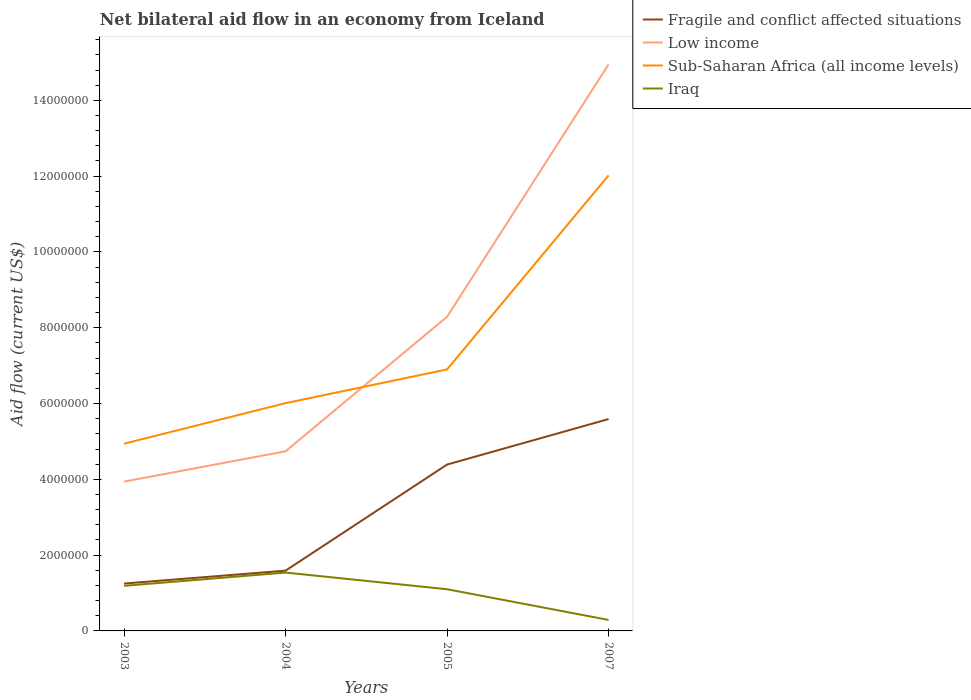How many different coloured lines are there?
Ensure brevity in your answer.  4. Does the line corresponding to Iraq intersect with the line corresponding to Sub-Saharan Africa (all income levels)?
Offer a very short reply. No. Across all years, what is the maximum net bilateral aid flow in Sub-Saharan Africa (all income levels)?
Give a very brief answer. 4.94e+06. In which year was the net bilateral aid flow in Fragile and conflict affected situations maximum?
Ensure brevity in your answer.  2003. What is the total net bilateral aid flow in Low income in the graph?
Ensure brevity in your answer.  -6.66e+06. What is the difference between the highest and the second highest net bilateral aid flow in Low income?
Ensure brevity in your answer.  1.10e+07. What is the difference between two consecutive major ticks on the Y-axis?
Your answer should be very brief. 2.00e+06. Are the values on the major ticks of Y-axis written in scientific E-notation?
Ensure brevity in your answer.  No. Does the graph contain grids?
Ensure brevity in your answer.  No. Where does the legend appear in the graph?
Your response must be concise. Top right. How are the legend labels stacked?
Ensure brevity in your answer.  Vertical. What is the title of the graph?
Give a very brief answer. Net bilateral aid flow in an economy from Iceland. What is the Aid flow (current US$) of Fragile and conflict affected situations in 2003?
Provide a succinct answer. 1.25e+06. What is the Aid flow (current US$) in Low income in 2003?
Provide a succinct answer. 3.94e+06. What is the Aid flow (current US$) in Sub-Saharan Africa (all income levels) in 2003?
Provide a short and direct response. 4.94e+06. What is the Aid flow (current US$) of Iraq in 2003?
Give a very brief answer. 1.19e+06. What is the Aid flow (current US$) in Fragile and conflict affected situations in 2004?
Your answer should be compact. 1.59e+06. What is the Aid flow (current US$) in Low income in 2004?
Provide a short and direct response. 4.74e+06. What is the Aid flow (current US$) in Sub-Saharan Africa (all income levels) in 2004?
Your answer should be compact. 6.01e+06. What is the Aid flow (current US$) in Iraq in 2004?
Your answer should be very brief. 1.54e+06. What is the Aid flow (current US$) of Fragile and conflict affected situations in 2005?
Make the answer very short. 4.39e+06. What is the Aid flow (current US$) in Low income in 2005?
Your response must be concise. 8.29e+06. What is the Aid flow (current US$) in Sub-Saharan Africa (all income levels) in 2005?
Your response must be concise. 6.90e+06. What is the Aid flow (current US$) in Iraq in 2005?
Your answer should be very brief. 1.10e+06. What is the Aid flow (current US$) of Fragile and conflict affected situations in 2007?
Offer a very short reply. 5.59e+06. What is the Aid flow (current US$) in Low income in 2007?
Your answer should be very brief. 1.50e+07. What is the Aid flow (current US$) in Sub-Saharan Africa (all income levels) in 2007?
Your response must be concise. 1.20e+07. What is the Aid flow (current US$) in Iraq in 2007?
Your answer should be compact. 2.90e+05. Across all years, what is the maximum Aid flow (current US$) of Fragile and conflict affected situations?
Provide a short and direct response. 5.59e+06. Across all years, what is the maximum Aid flow (current US$) of Low income?
Ensure brevity in your answer.  1.50e+07. Across all years, what is the maximum Aid flow (current US$) of Sub-Saharan Africa (all income levels)?
Your answer should be very brief. 1.20e+07. Across all years, what is the maximum Aid flow (current US$) of Iraq?
Ensure brevity in your answer.  1.54e+06. Across all years, what is the minimum Aid flow (current US$) in Fragile and conflict affected situations?
Keep it short and to the point. 1.25e+06. Across all years, what is the minimum Aid flow (current US$) in Low income?
Ensure brevity in your answer.  3.94e+06. Across all years, what is the minimum Aid flow (current US$) in Sub-Saharan Africa (all income levels)?
Offer a very short reply. 4.94e+06. Across all years, what is the minimum Aid flow (current US$) in Iraq?
Ensure brevity in your answer.  2.90e+05. What is the total Aid flow (current US$) in Fragile and conflict affected situations in the graph?
Your answer should be very brief. 1.28e+07. What is the total Aid flow (current US$) of Low income in the graph?
Make the answer very short. 3.19e+07. What is the total Aid flow (current US$) of Sub-Saharan Africa (all income levels) in the graph?
Make the answer very short. 2.99e+07. What is the total Aid flow (current US$) of Iraq in the graph?
Make the answer very short. 4.12e+06. What is the difference between the Aid flow (current US$) in Low income in 2003 and that in 2004?
Keep it short and to the point. -8.00e+05. What is the difference between the Aid flow (current US$) in Sub-Saharan Africa (all income levels) in 2003 and that in 2004?
Your response must be concise. -1.07e+06. What is the difference between the Aid flow (current US$) of Iraq in 2003 and that in 2004?
Give a very brief answer. -3.50e+05. What is the difference between the Aid flow (current US$) in Fragile and conflict affected situations in 2003 and that in 2005?
Provide a succinct answer. -3.14e+06. What is the difference between the Aid flow (current US$) of Low income in 2003 and that in 2005?
Keep it short and to the point. -4.35e+06. What is the difference between the Aid flow (current US$) of Sub-Saharan Africa (all income levels) in 2003 and that in 2005?
Make the answer very short. -1.96e+06. What is the difference between the Aid flow (current US$) in Iraq in 2003 and that in 2005?
Provide a short and direct response. 9.00e+04. What is the difference between the Aid flow (current US$) of Fragile and conflict affected situations in 2003 and that in 2007?
Offer a very short reply. -4.34e+06. What is the difference between the Aid flow (current US$) in Low income in 2003 and that in 2007?
Your answer should be compact. -1.10e+07. What is the difference between the Aid flow (current US$) in Sub-Saharan Africa (all income levels) in 2003 and that in 2007?
Offer a terse response. -7.08e+06. What is the difference between the Aid flow (current US$) in Fragile and conflict affected situations in 2004 and that in 2005?
Your response must be concise. -2.80e+06. What is the difference between the Aid flow (current US$) of Low income in 2004 and that in 2005?
Make the answer very short. -3.55e+06. What is the difference between the Aid flow (current US$) of Sub-Saharan Africa (all income levels) in 2004 and that in 2005?
Provide a short and direct response. -8.90e+05. What is the difference between the Aid flow (current US$) of Fragile and conflict affected situations in 2004 and that in 2007?
Provide a short and direct response. -4.00e+06. What is the difference between the Aid flow (current US$) of Low income in 2004 and that in 2007?
Ensure brevity in your answer.  -1.02e+07. What is the difference between the Aid flow (current US$) in Sub-Saharan Africa (all income levels) in 2004 and that in 2007?
Offer a terse response. -6.01e+06. What is the difference between the Aid flow (current US$) of Iraq in 2004 and that in 2007?
Your answer should be compact. 1.25e+06. What is the difference between the Aid flow (current US$) in Fragile and conflict affected situations in 2005 and that in 2007?
Provide a short and direct response. -1.20e+06. What is the difference between the Aid flow (current US$) of Low income in 2005 and that in 2007?
Make the answer very short. -6.66e+06. What is the difference between the Aid flow (current US$) of Sub-Saharan Africa (all income levels) in 2005 and that in 2007?
Your response must be concise. -5.12e+06. What is the difference between the Aid flow (current US$) of Iraq in 2005 and that in 2007?
Ensure brevity in your answer.  8.10e+05. What is the difference between the Aid flow (current US$) in Fragile and conflict affected situations in 2003 and the Aid flow (current US$) in Low income in 2004?
Offer a very short reply. -3.49e+06. What is the difference between the Aid flow (current US$) in Fragile and conflict affected situations in 2003 and the Aid flow (current US$) in Sub-Saharan Africa (all income levels) in 2004?
Your response must be concise. -4.76e+06. What is the difference between the Aid flow (current US$) in Fragile and conflict affected situations in 2003 and the Aid flow (current US$) in Iraq in 2004?
Your answer should be very brief. -2.90e+05. What is the difference between the Aid flow (current US$) of Low income in 2003 and the Aid flow (current US$) of Sub-Saharan Africa (all income levels) in 2004?
Your answer should be compact. -2.07e+06. What is the difference between the Aid flow (current US$) in Low income in 2003 and the Aid flow (current US$) in Iraq in 2004?
Offer a terse response. 2.40e+06. What is the difference between the Aid flow (current US$) in Sub-Saharan Africa (all income levels) in 2003 and the Aid flow (current US$) in Iraq in 2004?
Ensure brevity in your answer.  3.40e+06. What is the difference between the Aid flow (current US$) of Fragile and conflict affected situations in 2003 and the Aid flow (current US$) of Low income in 2005?
Your response must be concise. -7.04e+06. What is the difference between the Aid flow (current US$) of Fragile and conflict affected situations in 2003 and the Aid flow (current US$) of Sub-Saharan Africa (all income levels) in 2005?
Your answer should be very brief. -5.65e+06. What is the difference between the Aid flow (current US$) in Low income in 2003 and the Aid flow (current US$) in Sub-Saharan Africa (all income levels) in 2005?
Give a very brief answer. -2.96e+06. What is the difference between the Aid flow (current US$) in Low income in 2003 and the Aid flow (current US$) in Iraq in 2005?
Your response must be concise. 2.84e+06. What is the difference between the Aid flow (current US$) in Sub-Saharan Africa (all income levels) in 2003 and the Aid flow (current US$) in Iraq in 2005?
Provide a short and direct response. 3.84e+06. What is the difference between the Aid flow (current US$) of Fragile and conflict affected situations in 2003 and the Aid flow (current US$) of Low income in 2007?
Offer a terse response. -1.37e+07. What is the difference between the Aid flow (current US$) of Fragile and conflict affected situations in 2003 and the Aid flow (current US$) of Sub-Saharan Africa (all income levels) in 2007?
Make the answer very short. -1.08e+07. What is the difference between the Aid flow (current US$) in Fragile and conflict affected situations in 2003 and the Aid flow (current US$) in Iraq in 2007?
Provide a short and direct response. 9.60e+05. What is the difference between the Aid flow (current US$) of Low income in 2003 and the Aid flow (current US$) of Sub-Saharan Africa (all income levels) in 2007?
Ensure brevity in your answer.  -8.08e+06. What is the difference between the Aid flow (current US$) of Low income in 2003 and the Aid flow (current US$) of Iraq in 2007?
Your answer should be compact. 3.65e+06. What is the difference between the Aid flow (current US$) of Sub-Saharan Africa (all income levels) in 2003 and the Aid flow (current US$) of Iraq in 2007?
Offer a very short reply. 4.65e+06. What is the difference between the Aid flow (current US$) of Fragile and conflict affected situations in 2004 and the Aid flow (current US$) of Low income in 2005?
Provide a short and direct response. -6.70e+06. What is the difference between the Aid flow (current US$) in Fragile and conflict affected situations in 2004 and the Aid flow (current US$) in Sub-Saharan Africa (all income levels) in 2005?
Make the answer very short. -5.31e+06. What is the difference between the Aid flow (current US$) of Low income in 2004 and the Aid flow (current US$) of Sub-Saharan Africa (all income levels) in 2005?
Make the answer very short. -2.16e+06. What is the difference between the Aid flow (current US$) of Low income in 2004 and the Aid flow (current US$) of Iraq in 2005?
Your answer should be very brief. 3.64e+06. What is the difference between the Aid flow (current US$) in Sub-Saharan Africa (all income levels) in 2004 and the Aid flow (current US$) in Iraq in 2005?
Provide a short and direct response. 4.91e+06. What is the difference between the Aid flow (current US$) in Fragile and conflict affected situations in 2004 and the Aid flow (current US$) in Low income in 2007?
Your response must be concise. -1.34e+07. What is the difference between the Aid flow (current US$) of Fragile and conflict affected situations in 2004 and the Aid flow (current US$) of Sub-Saharan Africa (all income levels) in 2007?
Provide a succinct answer. -1.04e+07. What is the difference between the Aid flow (current US$) in Fragile and conflict affected situations in 2004 and the Aid flow (current US$) in Iraq in 2007?
Your response must be concise. 1.30e+06. What is the difference between the Aid flow (current US$) of Low income in 2004 and the Aid flow (current US$) of Sub-Saharan Africa (all income levels) in 2007?
Ensure brevity in your answer.  -7.28e+06. What is the difference between the Aid flow (current US$) of Low income in 2004 and the Aid flow (current US$) of Iraq in 2007?
Offer a very short reply. 4.45e+06. What is the difference between the Aid flow (current US$) in Sub-Saharan Africa (all income levels) in 2004 and the Aid flow (current US$) in Iraq in 2007?
Your response must be concise. 5.72e+06. What is the difference between the Aid flow (current US$) in Fragile and conflict affected situations in 2005 and the Aid flow (current US$) in Low income in 2007?
Offer a terse response. -1.06e+07. What is the difference between the Aid flow (current US$) of Fragile and conflict affected situations in 2005 and the Aid flow (current US$) of Sub-Saharan Africa (all income levels) in 2007?
Give a very brief answer. -7.63e+06. What is the difference between the Aid flow (current US$) in Fragile and conflict affected situations in 2005 and the Aid flow (current US$) in Iraq in 2007?
Your response must be concise. 4.10e+06. What is the difference between the Aid flow (current US$) in Low income in 2005 and the Aid flow (current US$) in Sub-Saharan Africa (all income levels) in 2007?
Your answer should be compact. -3.73e+06. What is the difference between the Aid flow (current US$) in Low income in 2005 and the Aid flow (current US$) in Iraq in 2007?
Your answer should be very brief. 8.00e+06. What is the difference between the Aid flow (current US$) of Sub-Saharan Africa (all income levels) in 2005 and the Aid flow (current US$) of Iraq in 2007?
Offer a very short reply. 6.61e+06. What is the average Aid flow (current US$) of Fragile and conflict affected situations per year?
Your answer should be compact. 3.20e+06. What is the average Aid flow (current US$) in Low income per year?
Keep it short and to the point. 7.98e+06. What is the average Aid flow (current US$) of Sub-Saharan Africa (all income levels) per year?
Give a very brief answer. 7.47e+06. What is the average Aid flow (current US$) of Iraq per year?
Your answer should be very brief. 1.03e+06. In the year 2003, what is the difference between the Aid flow (current US$) in Fragile and conflict affected situations and Aid flow (current US$) in Low income?
Keep it short and to the point. -2.69e+06. In the year 2003, what is the difference between the Aid flow (current US$) of Fragile and conflict affected situations and Aid flow (current US$) of Sub-Saharan Africa (all income levels)?
Offer a very short reply. -3.69e+06. In the year 2003, what is the difference between the Aid flow (current US$) in Low income and Aid flow (current US$) in Sub-Saharan Africa (all income levels)?
Ensure brevity in your answer.  -1.00e+06. In the year 2003, what is the difference between the Aid flow (current US$) in Low income and Aid flow (current US$) in Iraq?
Provide a short and direct response. 2.75e+06. In the year 2003, what is the difference between the Aid flow (current US$) of Sub-Saharan Africa (all income levels) and Aid flow (current US$) of Iraq?
Provide a short and direct response. 3.75e+06. In the year 2004, what is the difference between the Aid flow (current US$) in Fragile and conflict affected situations and Aid flow (current US$) in Low income?
Keep it short and to the point. -3.15e+06. In the year 2004, what is the difference between the Aid flow (current US$) of Fragile and conflict affected situations and Aid flow (current US$) of Sub-Saharan Africa (all income levels)?
Offer a very short reply. -4.42e+06. In the year 2004, what is the difference between the Aid flow (current US$) of Fragile and conflict affected situations and Aid flow (current US$) of Iraq?
Offer a very short reply. 5.00e+04. In the year 2004, what is the difference between the Aid flow (current US$) of Low income and Aid flow (current US$) of Sub-Saharan Africa (all income levels)?
Offer a very short reply. -1.27e+06. In the year 2004, what is the difference between the Aid flow (current US$) of Low income and Aid flow (current US$) of Iraq?
Ensure brevity in your answer.  3.20e+06. In the year 2004, what is the difference between the Aid flow (current US$) in Sub-Saharan Africa (all income levels) and Aid flow (current US$) in Iraq?
Offer a terse response. 4.47e+06. In the year 2005, what is the difference between the Aid flow (current US$) of Fragile and conflict affected situations and Aid flow (current US$) of Low income?
Your answer should be compact. -3.90e+06. In the year 2005, what is the difference between the Aid flow (current US$) in Fragile and conflict affected situations and Aid flow (current US$) in Sub-Saharan Africa (all income levels)?
Your answer should be compact. -2.51e+06. In the year 2005, what is the difference between the Aid flow (current US$) of Fragile and conflict affected situations and Aid flow (current US$) of Iraq?
Give a very brief answer. 3.29e+06. In the year 2005, what is the difference between the Aid flow (current US$) of Low income and Aid flow (current US$) of Sub-Saharan Africa (all income levels)?
Provide a succinct answer. 1.39e+06. In the year 2005, what is the difference between the Aid flow (current US$) in Low income and Aid flow (current US$) in Iraq?
Provide a short and direct response. 7.19e+06. In the year 2005, what is the difference between the Aid flow (current US$) in Sub-Saharan Africa (all income levels) and Aid flow (current US$) in Iraq?
Provide a short and direct response. 5.80e+06. In the year 2007, what is the difference between the Aid flow (current US$) of Fragile and conflict affected situations and Aid flow (current US$) of Low income?
Offer a terse response. -9.36e+06. In the year 2007, what is the difference between the Aid flow (current US$) in Fragile and conflict affected situations and Aid flow (current US$) in Sub-Saharan Africa (all income levels)?
Offer a very short reply. -6.43e+06. In the year 2007, what is the difference between the Aid flow (current US$) in Fragile and conflict affected situations and Aid flow (current US$) in Iraq?
Your answer should be very brief. 5.30e+06. In the year 2007, what is the difference between the Aid flow (current US$) in Low income and Aid flow (current US$) in Sub-Saharan Africa (all income levels)?
Keep it short and to the point. 2.93e+06. In the year 2007, what is the difference between the Aid flow (current US$) of Low income and Aid flow (current US$) of Iraq?
Provide a short and direct response. 1.47e+07. In the year 2007, what is the difference between the Aid flow (current US$) in Sub-Saharan Africa (all income levels) and Aid flow (current US$) in Iraq?
Ensure brevity in your answer.  1.17e+07. What is the ratio of the Aid flow (current US$) in Fragile and conflict affected situations in 2003 to that in 2004?
Provide a succinct answer. 0.79. What is the ratio of the Aid flow (current US$) of Low income in 2003 to that in 2004?
Provide a succinct answer. 0.83. What is the ratio of the Aid flow (current US$) of Sub-Saharan Africa (all income levels) in 2003 to that in 2004?
Provide a succinct answer. 0.82. What is the ratio of the Aid flow (current US$) in Iraq in 2003 to that in 2004?
Provide a short and direct response. 0.77. What is the ratio of the Aid flow (current US$) of Fragile and conflict affected situations in 2003 to that in 2005?
Offer a terse response. 0.28. What is the ratio of the Aid flow (current US$) in Low income in 2003 to that in 2005?
Provide a succinct answer. 0.48. What is the ratio of the Aid flow (current US$) in Sub-Saharan Africa (all income levels) in 2003 to that in 2005?
Give a very brief answer. 0.72. What is the ratio of the Aid flow (current US$) of Iraq in 2003 to that in 2005?
Ensure brevity in your answer.  1.08. What is the ratio of the Aid flow (current US$) of Fragile and conflict affected situations in 2003 to that in 2007?
Your response must be concise. 0.22. What is the ratio of the Aid flow (current US$) of Low income in 2003 to that in 2007?
Keep it short and to the point. 0.26. What is the ratio of the Aid flow (current US$) in Sub-Saharan Africa (all income levels) in 2003 to that in 2007?
Ensure brevity in your answer.  0.41. What is the ratio of the Aid flow (current US$) in Iraq in 2003 to that in 2007?
Make the answer very short. 4.1. What is the ratio of the Aid flow (current US$) of Fragile and conflict affected situations in 2004 to that in 2005?
Make the answer very short. 0.36. What is the ratio of the Aid flow (current US$) in Low income in 2004 to that in 2005?
Your answer should be very brief. 0.57. What is the ratio of the Aid flow (current US$) in Sub-Saharan Africa (all income levels) in 2004 to that in 2005?
Provide a succinct answer. 0.87. What is the ratio of the Aid flow (current US$) in Fragile and conflict affected situations in 2004 to that in 2007?
Ensure brevity in your answer.  0.28. What is the ratio of the Aid flow (current US$) in Low income in 2004 to that in 2007?
Your answer should be very brief. 0.32. What is the ratio of the Aid flow (current US$) of Sub-Saharan Africa (all income levels) in 2004 to that in 2007?
Offer a very short reply. 0.5. What is the ratio of the Aid flow (current US$) of Iraq in 2004 to that in 2007?
Offer a very short reply. 5.31. What is the ratio of the Aid flow (current US$) of Fragile and conflict affected situations in 2005 to that in 2007?
Provide a short and direct response. 0.79. What is the ratio of the Aid flow (current US$) of Low income in 2005 to that in 2007?
Offer a terse response. 0.55. What is the ratio of the Aid flow (current US$) of Sub-Saharan Africa (all income levels) in 2005 to that in 2007?
Make the answer very short. 0.57. What is the ratio of the Aid flow (current US$) of Iraq in 2005 to that in 2007?
Offer a terse response. 3.79. What is the difference between the highest and the second highest Aid flow (current US$) of Fragile and conflict affected situations?
Offer a terse response. 1.20e+06. What is the difference between the highest and the second highest Aid flow (current US$) of Low income?
Make the answer very short. 6.66e+06. What is the difference between the highest and the second highest Aid flow (current US$) of Sub-Saharan Africa (all income levels)?
Your answer should be compact. 5.12e+06. What is the difference between the highest and the second highest Aid flow (current US$) of Iraq?
Provide a short and direct response. 3.50e+05. What is the difference between the highest and the lowest Aid flow (current US$) in Fragile and conflict affected situations?
Offer a terse response. 4.34e+06. What is the difference between the highest and the lowest Aid flow (current US$) in Low income?
Your response must be concise. 1.10e+07. What is the difference between the highest and the lowest Aid flow (current US$) of Sub-Saharan Africa (all income levels)?
Offer a terse response. 7.08e+06. What is the difference between the highest and the lowest Aid flow (current US$) of Iraq?
Offer a very short reply. 1.25e+06. 